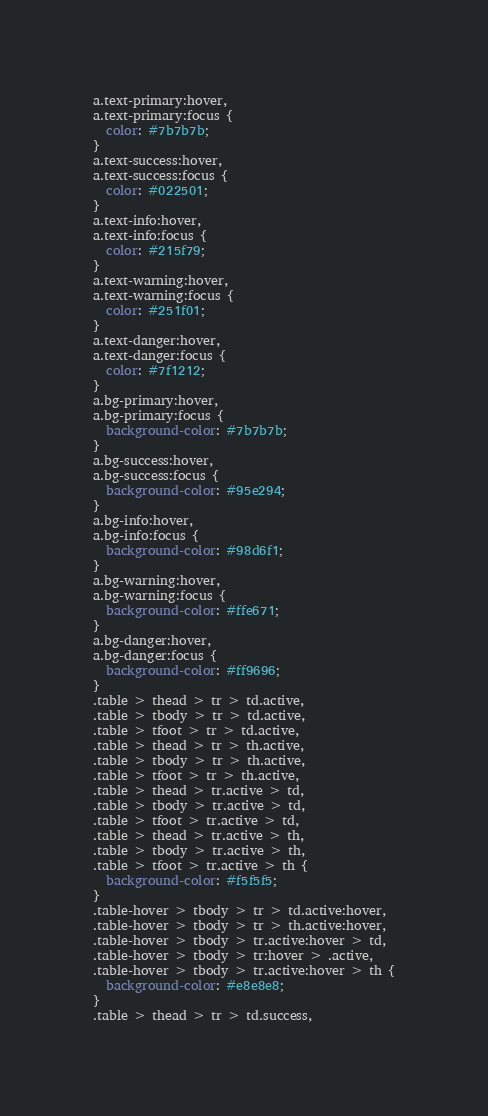Convert code to text. <code><loc_0><loc_0><loc_500><loc_500><_CSS_>a.text-primary:hover,
a.text-primary:focus {
  color: #7b7b7b;
}
a.text-success:hover,
a.text-success:focus {
  color: #022501;
}
a.text-info:hover,
a.text-info:focus {
  color: #215f79;
}
a.text-warning:hover,
a.text-warning:focus {
  color: #251f01;
}
a.text-danger:hover,
a.text-danger:focus {
  color: #7f1212;
}
a.bg-primary:hover,
a.bg-primary:focus {
  background-color: #7b7b7b;
}
a.bg-success:hover,
a.bg-success:focus {
  background-color: #95e294;
}
a.bg-info:hover,
a.bg-info:focus {
  background-color: #98d6f1;
}
a.bg-warning:hover,
a.bg-warning:focus {
  background-color: #ffe671;
}
a.bg-danger:hover,
a.bg-danger:focus {
  background-color: #ff9696;
}
.table > thead > tr > td.active,
.table > tbody > tr > td.active,
.table > tfoot > tr > td.active,
.table > thead > tr > th.active,
.table > tbody > tr > th.active,
.table > tfoot > tr > th.active,
.table > thead > tr.active > td,
.table > tbody > tr.active > td,
.table > tfoot > tr.active > td,
.table > thead > tr.active > th,
.table > tbody > tr.active > th,
.table > tfoot > tr.active > th {
  background-color: #f5f5f5;
}
.table-hover > tbody > tr > td.active:hover,
.table-hover > tbody > tr > th.active:hover,
.table-hover > tbody > tr.active:hover > td,
.table-hover > tbody > tr:hover > .active,
.table-hover > tbody > tr.active:hover > th {
  background-color: #e8e8e8;
}
.table > thead > tr > td.success,</code> 